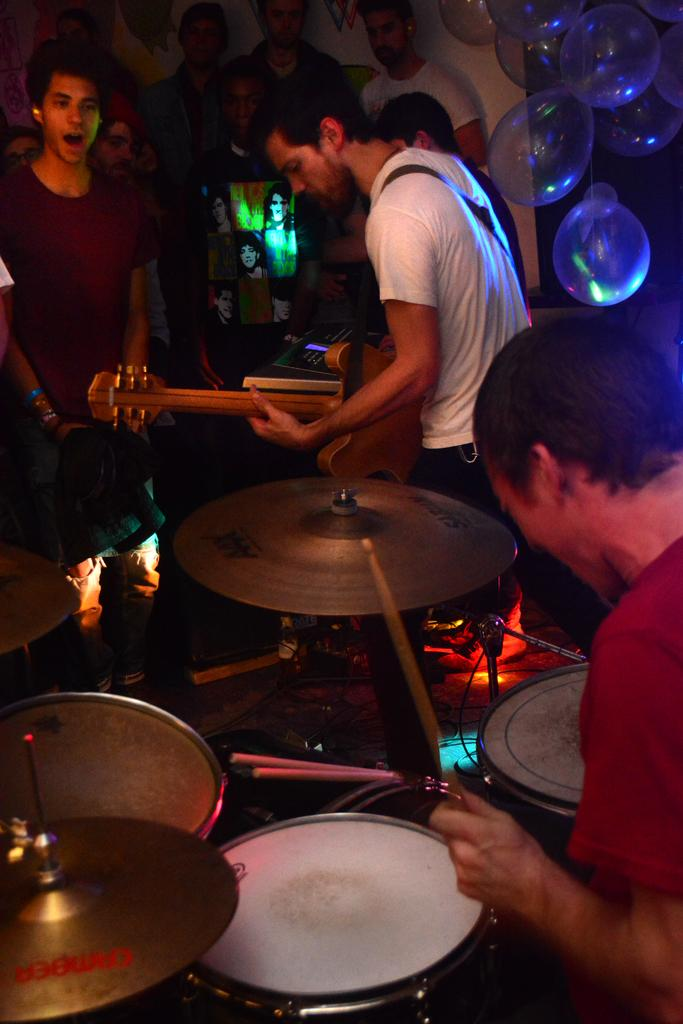What are the two persons in the image doing? The two persons in the image are playing musical instruments. What can be seen on the right side of the image? There are balloons on the right side of the image. What is happening on the left side of the image? There are people standing on the left side of the image. Can you describe the earthquake happening in the image? There is no earthquake depicted in the image. What type of play is being performed by the people in the image? The image does not show any play being performed; it features two persons playing musical instruments and people standing nearby. 